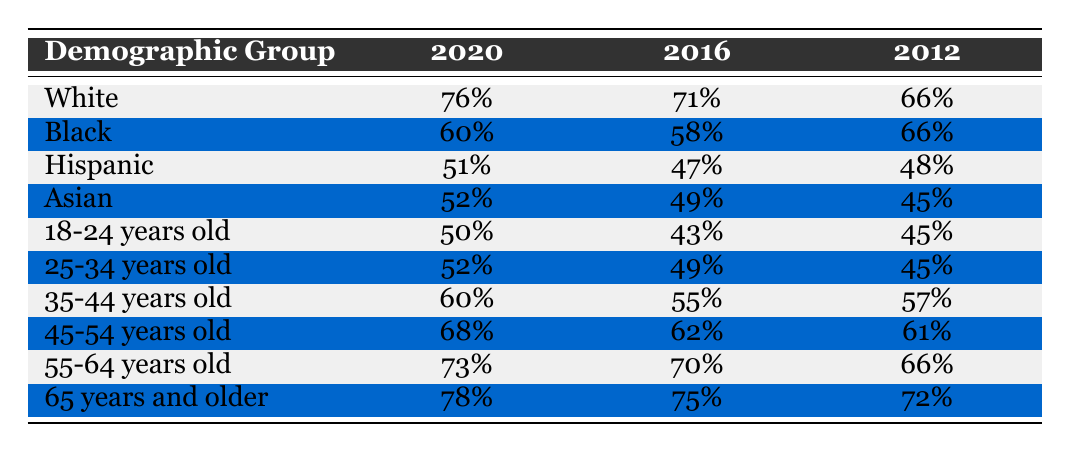What was the voter turnout for White demographic group in 2020? The table shows a specific row for the White demographic group, and under the column for 2020, the value is 76%.
Answer: 76% Which demographic group had the lowest voter turnout in 2020? Looking through the table, the Hispanic group has the lowest value for 2020, which is 51%.
Answer: Hispanic What is the difference in voter turnout for Black demographic group between 2016 and 2020? For the Black demographic group, the turnout in 2020 is 60% and in 2016 it was 58%. The difference is calculated as 60% - 58% = 2%.
Answer: 2% What is the average voter turnout for the age group 18-24 years old over the years 2012, 2016, and 2020? The values for the age group 18-24 are 45% for 2012, 43% for 2016, and 50% for 2020. The average is calculated as (45% + 43% + 50%) / 3 = 46%.
Answer: 46% Is the voter turnout for the demographic group 65 years and older increasing over the years? Looking at the table, the values are 72% for 2012, 75% for 2016, and 78% for 2020, showing a consistent increase.
Answer: Yes What was the voter turnout for the 25-34 years old age group in 2016, and how does it compare to 2012? The voter turnout for the 25-34 age group in 2016 is 49% and in 2012 it was 45%, which means it increased by (49% - 45%) = 4%.
Answer: 49%, increased by 4% What is the trend of voter turnout for the Hispanic demographic group from 2012 to 2020? The voter turnout values for the Hispanic demographic group are 48% in 2012, 47% in 2016, and 51% in 2020. This shows a drop between 2012 and 2016, but an increase in 2020.
Answer: Decreased, then increased How does the voter turnout for the Asian demographic compare to the Black demographic in 2020? In 2020, the turnout for the Asian demographic is 52% and for the Black demographic it is 60%. Comparing these, 52% is less than 60%, indicating that Black turnout is higher.
Answer: Black demographic had higher turnout What percentage of voters aged 55-64 participated in the election in 2016? The table directly provides the value for the voter turnout of the 55-64 age group in 2016, which is 70%.
Answer: 70% 